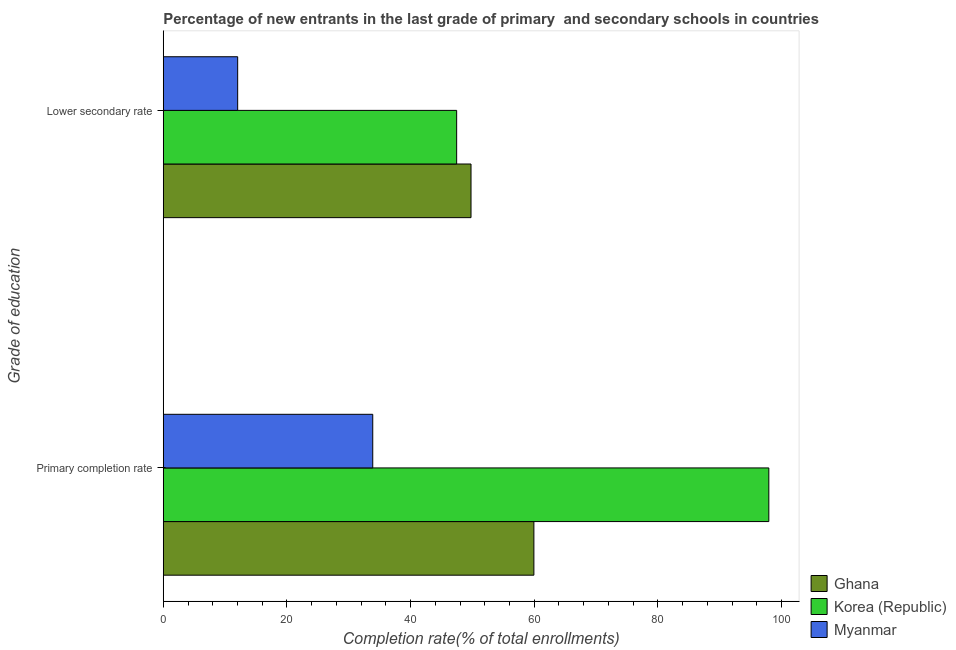How many groups of bars are there?
Make the answer very short. 2. How many bars are there on the 1st tick from the top?
Keep it short and to the point. 3. How many bars are there on the 1st tick from the bottom?
Provide a succinct answer. 3. What is the label of the 2nd group of bars from the top?
Provide a succinct answer. Primary completion rate. What is the completion rate in secondary schools in Korea (Republic)?
Your response must be concise. 47.45. Across all countries, what is the maximum completion rate in secondary schools?
Your answer should be very brief. 49.78. Across all countries, what is the minimum completion rate in secondary schools?
Give a very brief answer. 12.03. In which country was the completion rate in secondary schools maximum?
Provide a short and direct response. Ghana. In which country was the completion rate in secondary schools minimum?
Your answer should be compact. Myanmar. What is the total completion rate in primary schools in the graph?
Make the answer very short. 191.77. What is the difference between the completion rate in secondary schools in Ghana and that in Korea (Republic)?
Give a very brief answer. 2.32. What is the difference between the completion rate in secondary schools in Ghana and the completion rate in primary schools in Myanmar?
Offer a very short reply. 15.89. What is the average completion rate in primary schools per country?
Keep it short and to the point. 63.92. What is the difference between the completion rate in secondary schools and completion rate in primary schools in Korea (Republic)?
Provide a short and direct response. -50.49. What is the ratio of the completion rate in primary schools in Korea (Republic) to that in Ghana?
Give a very brief answer. 1.63. What does the 2nd bar from the top in Primary completion rate represents?
Keep it short and to the point. Korea (Republic). How many countries are there in the graph?
Give a very brief answer. 3. Are the values on the major ticks of X-axis written in scientific E-notation?
Make the answer very short. No. Does the graph contain any zero values?
Provide a short and direct response. No. Does the graph contain grids?
Your response must be concise. No. How many legend labels are there?
Your answer should be compact. 3. What is the title of the graph?
Your answer should be very brief. Percentage of new entrants in the last grade of primary  and secondary schools in countries. What is the label or title of the X-axis?
Your answer should be compact. Completion rate(% of total enrollments). What is the label or title of the Y-axis?
Your response must be concise. Grade of education. What is the Completion rate(% of total enrollments) in Ghana in Primary completion rate?
Provide a short and direct response. 59.95. What is the Completion rate(% of total enrollments) of Korea (Republic) in Primary completion rate?
Your response must be concise. 97.95. What is the Completion rate(% of total enrollments) in Myanmar in Primary completion rate?
Keep it short and to the point. 33.88. What is the Completion rate(% of total enrollments) in Ghana in Lower secondary rate?
Give a very brief answer. 49.78. What is the Completion rate(% of total enrollments) in Korea (Republic) in Lower secondary rate?
Offer a terse response. 47.45. What is the Completion rate(% of total enrollments) in Myanmar in Lower secondary rate?
Your response must be concise. 12.03. Across all Grade of education, what is the maximum Completion rate(% of total enrollments) in Ghana?
Provide a succinct answer. 59.95. Across all Grade of education, what is the maximum Completion rate(% of total enrollments) of Korea (Republic)?
Give a very brief answer. 97.95. Across all Grade of education, what is the maximum Completion rate(% of total enrollments) in Myanmar?
Your answer should be very brief. 33.88. Across all Grade of education, what is the minimum Completion rate(% of total enrollments) of Ghana?
Your answer should be very brief. 49.78. Across all Grade of education, what is the minimum Completion rate(% of total enrollments) of Korea (Republic)?
Provide a short and direct response. 47.45. Across all Grade of education, what is the minimum Completion rate(% of total enrollments) in Myanmar?
Provide a short and direct response. 12.03. What is the total Completion rate(% of total enrollments) of Ghana in the graph?
Give a very brief answer. 109.72. What is the total Completion rate(% of total enrollments) in Korea (Republic) in the graph?
Ensure brevity in your answer.  145.4. What is the total Completion rate(% of total enrollments) of Myanmar in the graph?
Your response must be concise. 45.92. What is the difference between the Completion rate(% of total enrollments) of Ghana in Primary completion rate and that in Lower secondary rate?
Make the answer very short. 10.17. What is the difference between the Completion rate(% of total enrollments) in Korea (Republic) in Primary completion rate and that in Lower secondary rate?
Offer a very short reply. 50.49. What is the difference between the Completion rate(% of total enrollments) of Myanmar in Primary completion rate and that in Lower secondary rate?
Your response must be concise. 21.85. What is the difference between the Completion rate(% of total enrollments) of Ghana in Primary completion rate and the Completion rate(% of total enrollments) of Korea (Republic) in Lower secondary rate?
Provide a short and direct response. 12.49. What is the difference between the Completion rate(% of total enrollments) in Ghana in Primary completion rate and the Completion rate(% of total enrollments) in Myanmar in Lower secondary rate?
Your answer should be very brief. 47.91. What is the difference between the Completion rate(% of total enrollments) of Korea (Republic) in Primary completion rate and the Completion rate(% of total enrollments) of Myanmar in Lower secondary rate?
Give a very brief answer. 85.91. What is the average Completion rate(% of total enrollments) in Ghana per Grade of education?
Your response must be concise. 54.86. What is the average Completion rate(% of total enrollments) of Korea (Republic) per Grade of education?
Provide a short and direct response. 72.7. What is the average Completion rate(% of total enrollments) of Myanmar per Grade of education?
Offer a terse response. 22.96. What is the difference between the Completion rate(% of total enrollments) of Ghana and Completion rate(% of total enrollments) of Korea (Republic) in Primary completion rate?
Keep it short and to the point. -38. What is the difference between the Completion rate(% of total enrollments) in Ghana and Completion rate(% of total enrollments) in Myanmar in Primary completion rate?
Ensure brevity in your answer.  26.06. What is the difference between the Completion rate(% of total enrollments) of Korea (Republic) and Completion rate(% of total enrollments) of Myanmar in Primary completion rate?
Offer a terse response. 64.06. What is the difference between the Completion rate(% of total enrollments) of Ghana and Completion rate(% of total enrollments) of Korea (Republic) in Lower secondary rate?
Offer a very short reply. 2.32. What is the difference between the Completion rate(% of total enrollments) of Ghana and Completion rate(% of total enrollments) of Myanmar in Lower secondary rate?
Your response must be concise. 37.74. What is the difference between the Completion rate(% of total enrollments) of Korea (Republic) and Completion rate(% of total enrollments) of Myanmar in Lower secondary rate?
Keep it short and to the point. 35.42. What is the ratio of the Completion rate(% of total enrollments) of Ghana in Primary completion rate to that in Lower secondary rate?
Offer a terse response. 1.2. What is the ratio of the Completion rate(% of total enrollments) in Korea (Republic) in Primary completion rate to that in Lower secondary rate?
Offer a very short reply. 2.06. What is the ratio of the Completion rate(% of total enrollments) of Myanmar in Primary completion rate to that in Lower secondary rate?
Offer a very short reply. 2.82. What is the difference between the highest and the second highest Completion rate(% of total enrollments) in Ghana?
Offer a very short reply. 10.17. What is the difference between the highest and the second highest Completion rate(% of total enrollments) in Korea (Republic)?
Give a very brief answer. 50.49. What is the difference between the highest and the second highest Completion rate(% of total enrollments) in Myanmar?
Ensure brevity in your answer.  21.85. What is the difference between the highest and the lowest Completion rate(% of total enrollments) of Ghana?
Keep it short and to the point. 10.17. What is the difference between the highest and the lowest Completion rate(% of total enrollments) in Korea (Republic)?
Provide a succinct answer. 50.49. What is the difference between the highest and the lowest Completion rate(% of total enrollments) of Myanmar?
Ensure brevity in your answer.  21.85. 